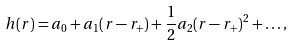Convert formula to latex. <formula><loc_0><loc_0><loc_500><loc_500>h ( r ) = a _ { 0 } + a _ { 1 } ( r - r _ { + } ) + \frac { 1 } { 2 } a _ { 2 } ( r - r _ { + } ) ^ { 2 } + \dots , \label a { T a y l o r }</formula> 